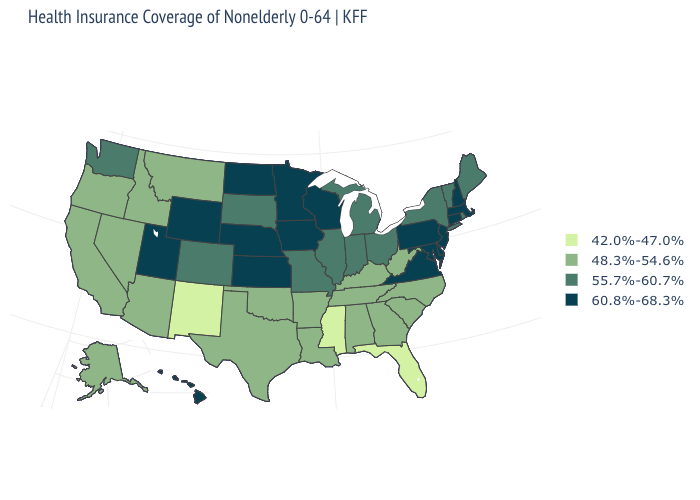Does Idaho have the same value as Maine?
Quick response, please. No. Does the first symbol in the legend represent the smallest category?
Short answer required. Yes. How many symbols are there in the legend?
Short answer required. 4. Does New Jersey have the highest value in the Northeast?
Be succinct. Yes. What is the highest value in the USA?
Answer briefly. 60.8%-68.3%. What is the value of West Virginia?
Quick response, please. 48.3%-54.6%. Name the states that have a value in the range 60.8%-68.3%?
Quick response, please. Connecticut, Delaware, Hawaii, Iowa, Kansas, Maryland, Massachusetts, Minnesota, Nebraska, New Hampshire, New Jersey, North Dakota, Pennsylvania, Utah, Virginia, Wisconsin, Wyoming. Is the legend a continuous bar?
Give a very brief answer. No. Does Delaware have the highest value in the USA?
Be succinct. Yes. Does Connecticut have the highest value in the Northeast?
Keep it brief. Yes. What is the value of Arkansas?
Be succinct. 48.3%-54.6%. What is the value of Tennessee?
Answer briefly. 48.3%-54.6%. Does the first symbol in the legend represent the smallest category?
Answer briefly. Yes. Which states have the highest value in the USA?
Give a very brief answer. Connecticut, Delaware, Hawaii, Iowa, Kansas, Maryland, Massachusetts, Minnesota, Nebraska, New Hampshire, New Jersey, North Dakota, Pennsylvania, Utah, Virginia, Wisconsin, Wyoming. Among the states that border Tennessee , which have the lowest value?
Quick response, please. Mississippi. 